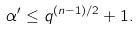Convert formula to latex. <formula><loc_0><loc_0><loc_500><loc_500>\alpha ^ { \prime } \leq q ^ { ( n - 1 ) / 2 } + 1 .</formula> 